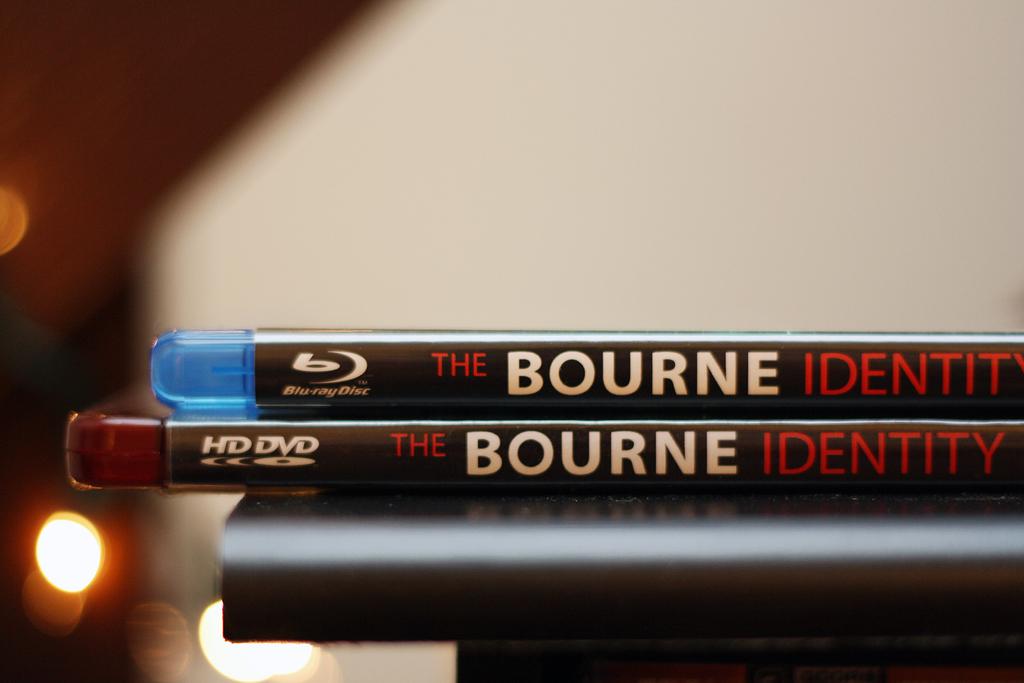What type of disc is the bottom one?
Make the answer very short. Hd dvd. 